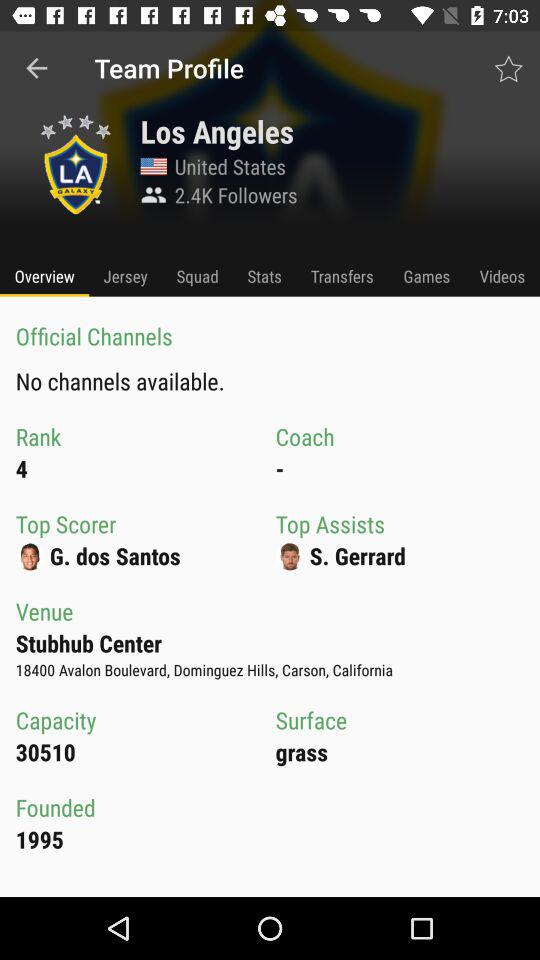When was it founded? It was founded in 1995. 